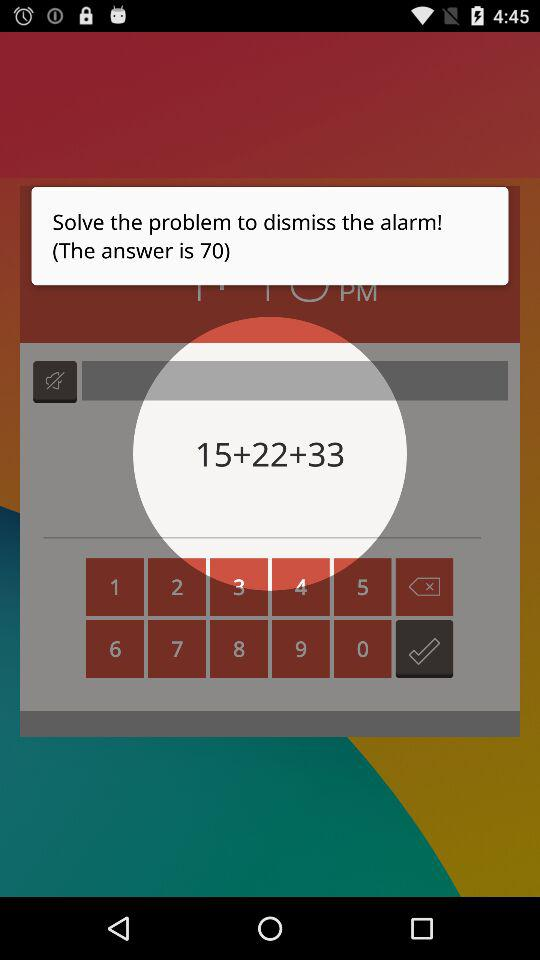What is the answer? The answer is 70. 